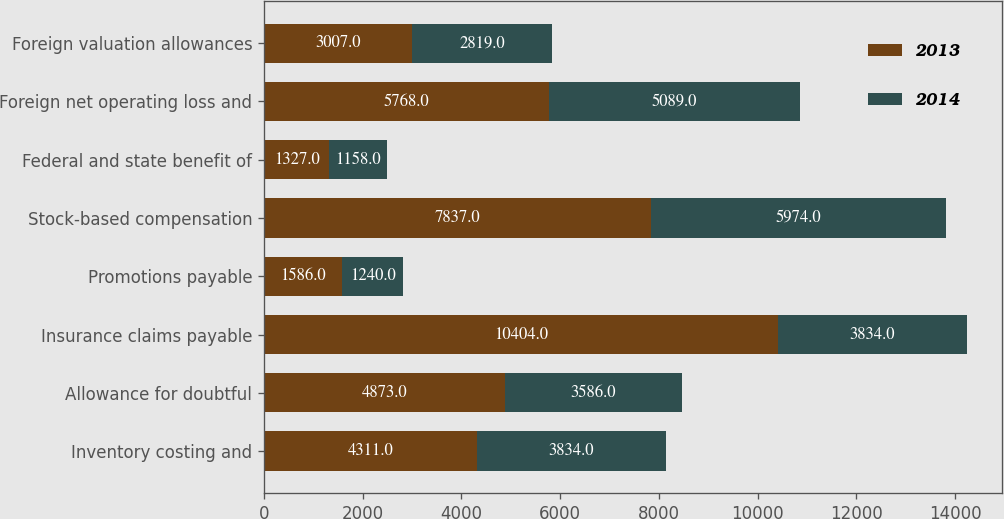Convert chart to OTSL. <chart><loc_0><loc_0><loc_500><loc_500><stacked_bar_chart><ecel><fcel>Inventory costing and<fcel>Allowance for doubtful<fcel>Insurance claims payable<fcel>Promotions payable<fcel>Stock-based compensation<fcel>Federal and state benefit of<fcel>Foreign net operating loss and<fcel>Foreign valuation allowances<nl><fcel>2013<fcel>4311<fcel>4873<fcel>10404<fcel>1586<fcel>7837<fcel>1327<fcel>5768<fcel>3007<nl><fcel>2014<fcel>3834<fcel>3586<fcel>3834<fcel>1240<fcel>5974<fcel>1158<fcel>5089<fcel>2819<nl></chart> 